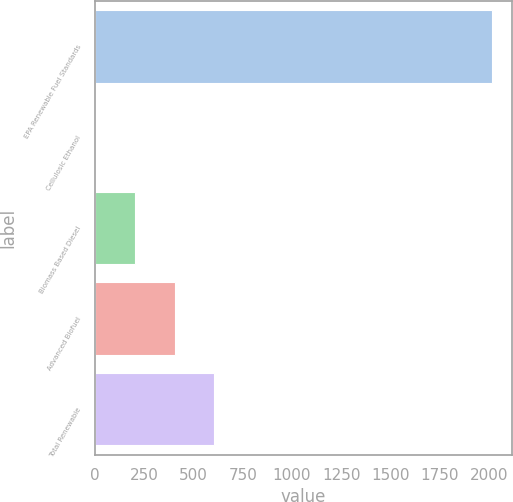<chart> <loc_0><loc_0><loc_500><loc_500><bar_chart><fcel>EPA Renewable Fuel Standards<fcel>Cellulosic Ethanol<fcel>Biomass Based Diesel<fcel>Advanced Biofuel<fcel>Total Renewable<nl><fcel>2015<fcel>0.12<fcel>201.61<fcel>403.1<fcel>604.59<nl></chart> 